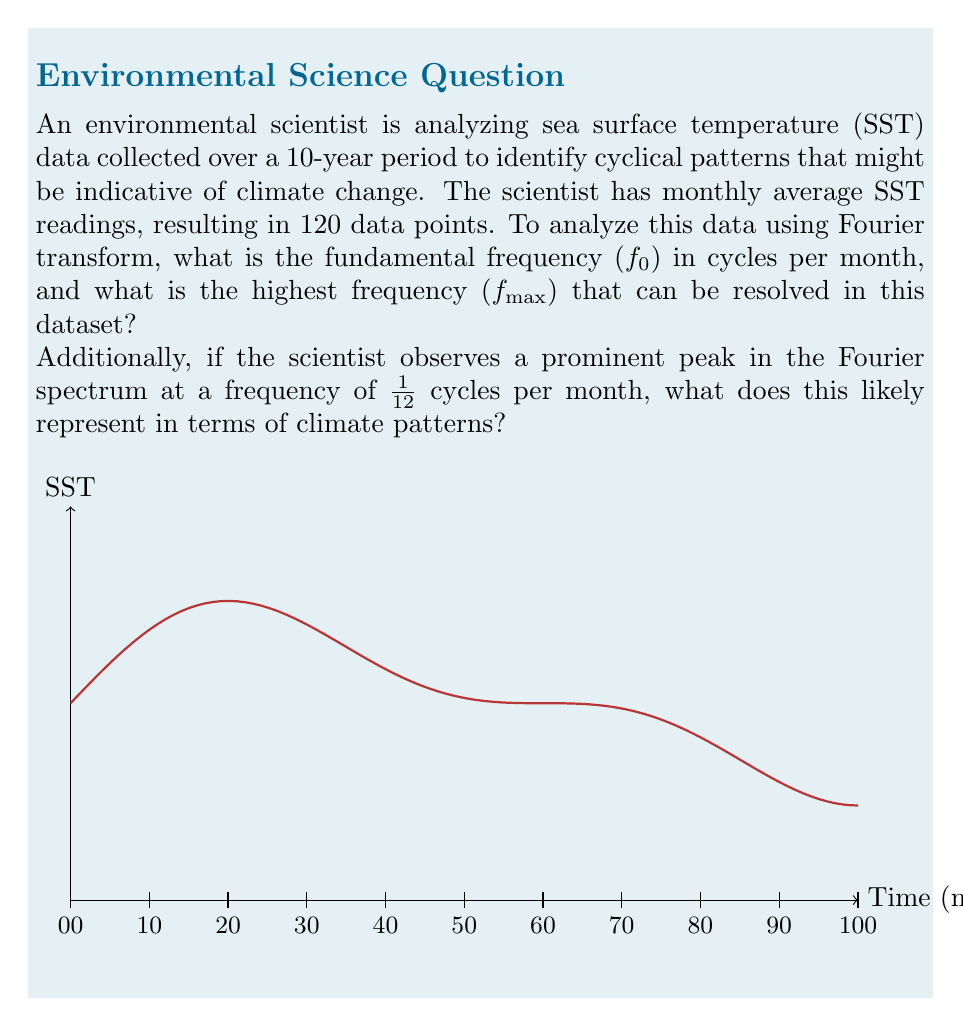Can you answer this question? To solve this problem, we need to apply the principles of Fourier transform and the Nyquist-Shannon sampling theorem. Let's break it down step-by-step:

1. Fundamental frequency (f₀):
   The fundamental frequency is the reciprocal of the total time period.
   Total time period = 10 years = 120 months
   $$f_0 = \frac{1}{120} \text{ cycles/month}$$

2. Highest resolvable frequency (fmax):
   According to the Nyquist-Shannon sampling theorem, the highest frequency that can be resolved is half the sampling frequency.
   Sampling frequency = 1 sample/month
   $$f_{max} = \frac{1}{2} \cdot 1 \text{ sample/month} = \frac{1}{2} \text{ cycles/month}$$

3. Interpretation of the peak at 1/12 cycles per month:
   A frequency of 1/12 cycles per month corresponds to a period of 12 months, which represents an annual cycle. In climate data, this likely indicates a strong yearly seasonal pattern in sea surface temperatures.

   To verify this, we can calculate the period:
   $$T = \frac{1}{f} = \frac{1}{1/12} = 12 \text{ months}$$

   This 12-month cycle aligns with the Earth's annual orbit around the Sun, which is the primary driver of seasonal temperature variations.

In the context of climate change research, identifying and quantifying this annual cycle is crucial for:
a) Removing seasonal effects to isolate long-term trends
b) Detecting changes in the amplitude or phase of seasonal patterns over time, which could be indicators of climate change impacts

The Fourier transform allows the scientist to decompose the complex SST signal into its constituent frequencies, making it easier to identify and analyze various cyclical patterns in the data.
Answer: f₀ = 1/120 cycles/month, fmax = 1/2 cycles/month. Peak at 1/12 cycles/month represents annual seasonal cycle. 